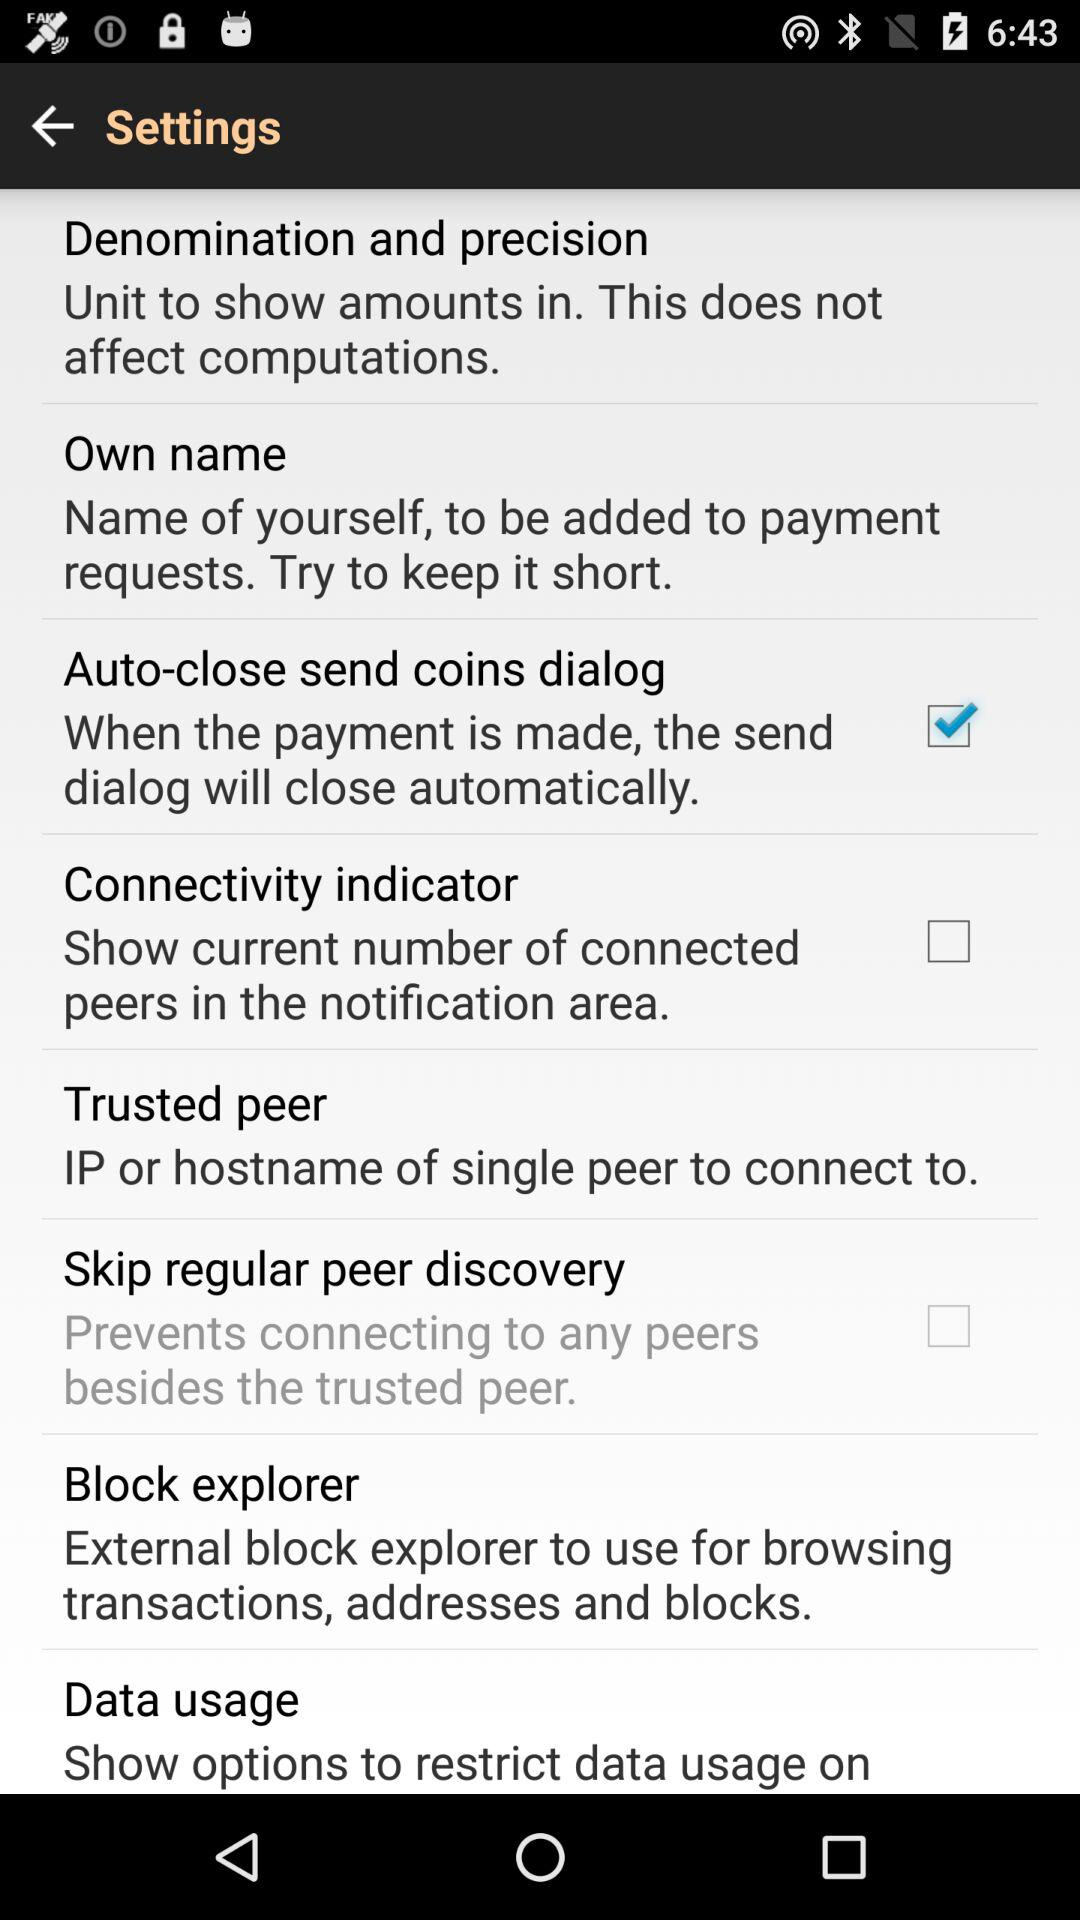What is the status of the "Auto-close send coins dialog"? The status of the "Auto-close send coins dialog" is "on". 